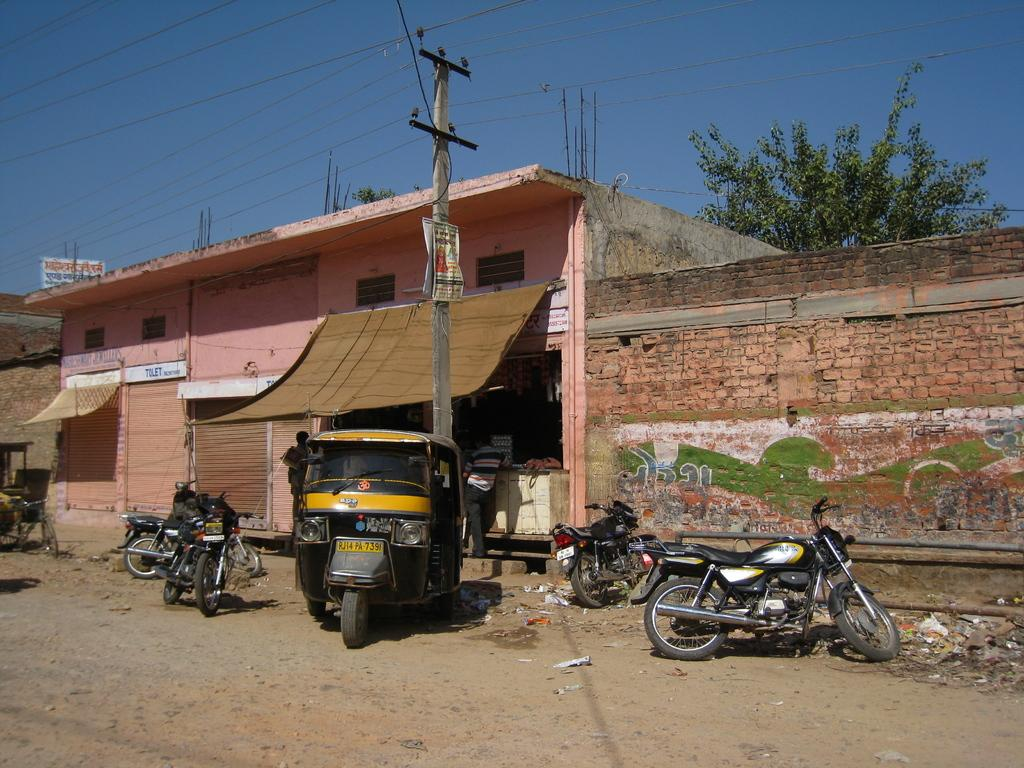What type of vehicles are present in the image? There are bikes in the image. What is the color of the auto in the image? The auto in the image is black. What type of establishments can be seen in the image? There are shops visible in the image. What structure is present near the vehicles? There is an electric pole in the image. What is the color of the sky in the image? The sky is blue and visible at the top of the image. Can you see a collar on any of the bikes in the image? There are no collars present on the bikes in the image. Is there a boat visible in the image? There is no boat present in the image. 